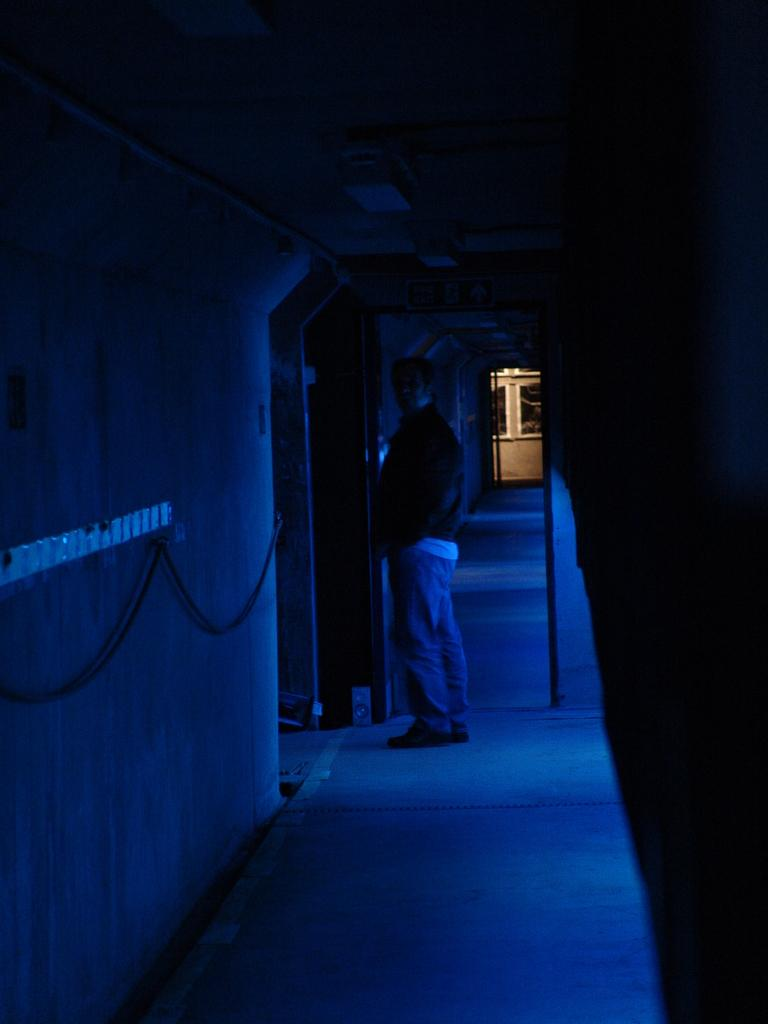What is the main subject in the image? There is a man standing in the image. What is the man standing on? The man is standing on the floor. What other objects can be seen in the image? There is a board in the image. What is the ceiling like in the image? There is a ceiling in the image. What is the wall like in the image? There is a wall in the image. How many units of dolls are present in the image? There are no dolls present in the image. What type of quarter is visible in the image? There is no quarter present in the image. 